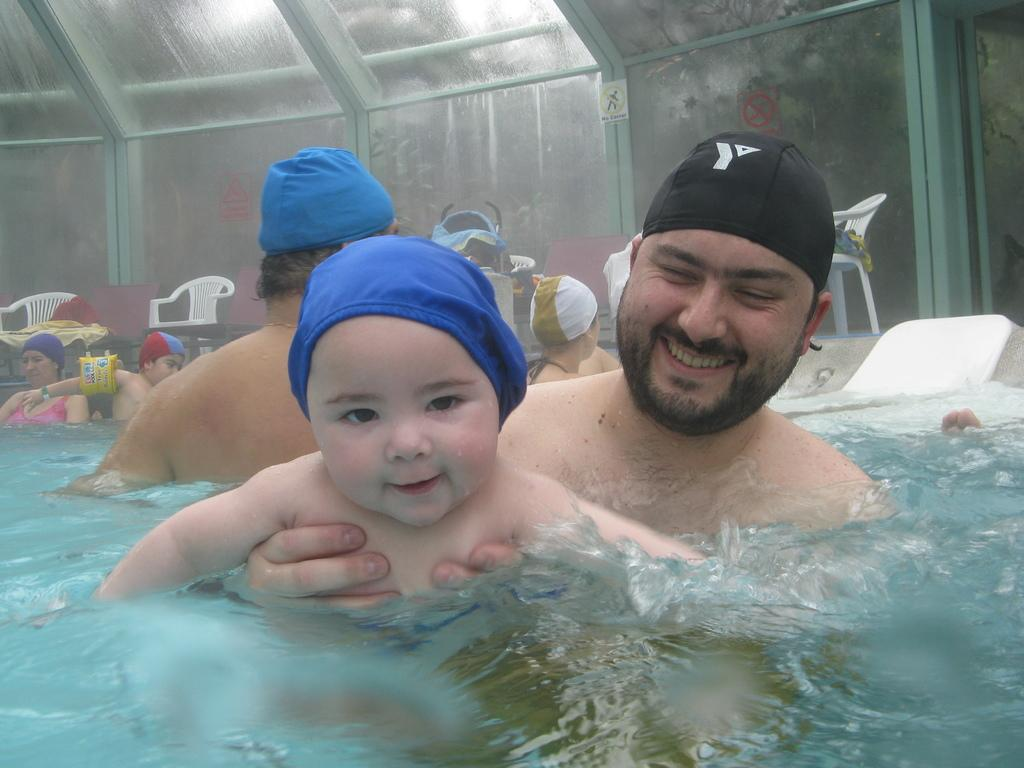What are the people in the image doing? The people in the image are swimming in the water. What are the people wearing while swimming? The people are wearing head caps. What can be seen in the background of the image? There are chairs on the ground in the background. What type of war is being fought in the image? There is no war present in the image; it features people swimming in the water. What mode of transport is being used by the people in the image? The people in the image are swimming, so no specific mode of transport is being used. 